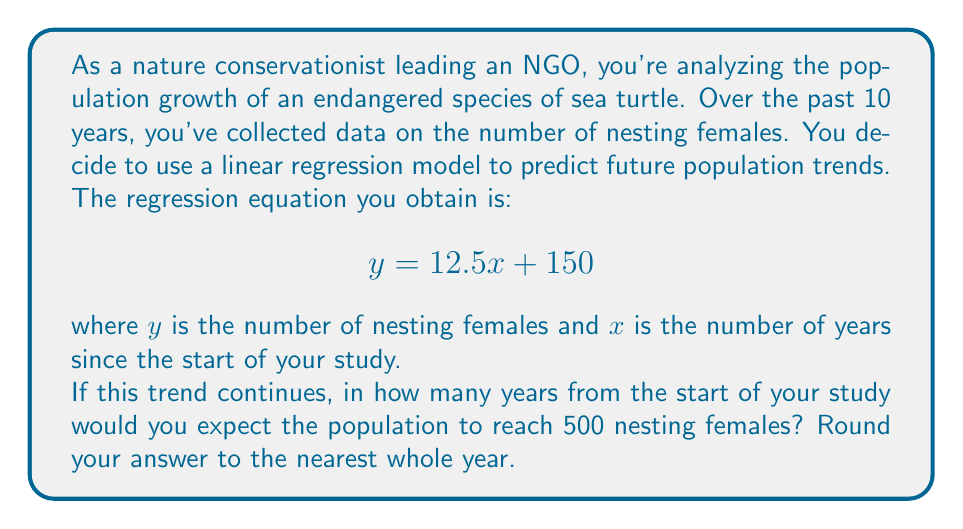Help me with this question. To solve this problem, we need to use the given linear regression equation and solve for $x$ when $y = 500$. Here's the step-by-step process:

1) The linear regression equation is:
   $$y = 12.5x + 150$$

2) We want to find $x$ when $y = 500$. So, let's substitute $y$ with 500:
   $$500 = 12.5x + 150$$

3) Now, let's solve for $x$:
   Subtract 150 from both sides:
   $$350 = 12.5x$$

   Divide both sides by 12.5:
   $$\frac{350}{12.5} = x$$

4) Calculate the result:
   $$x = 28$$

5) Since we're asked to round to the nearest whole year, 28 is already a whole number, so no further rounding is necessary.

This means that if the current trend continues, we would expect the population to reach 500 nesting females 28 years from the start of the study.
Answer: 28 years 